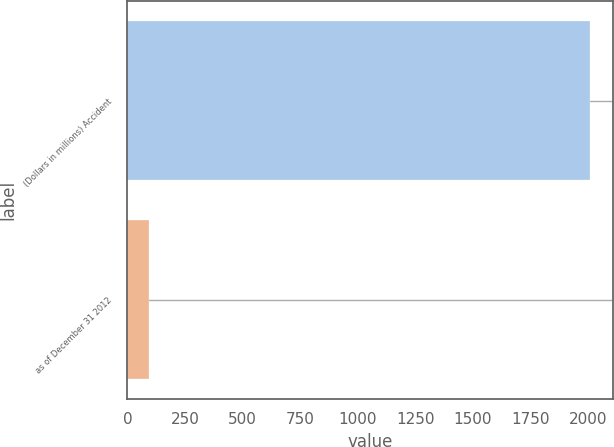<chart> <loc_0><loc_0><loc_500><loc_500><bar_chart><fcel>(Dollars in millions) Accident<fcel>as of December 31 2012<nl><fcel>2011<fcel>92.5<nl></chart> 